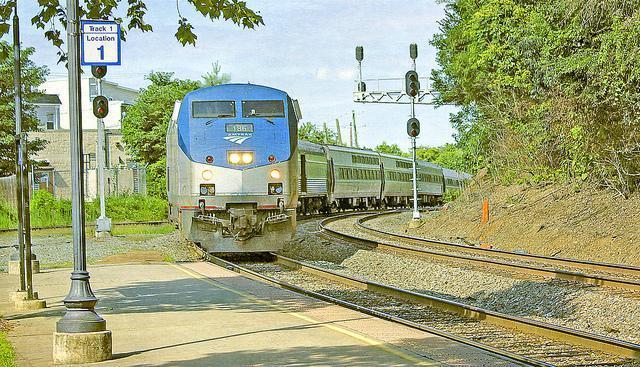How many trains are there?
Give a very brief answer. 1. How many people are on the ski lift?
Give a very brief answer. 0. 